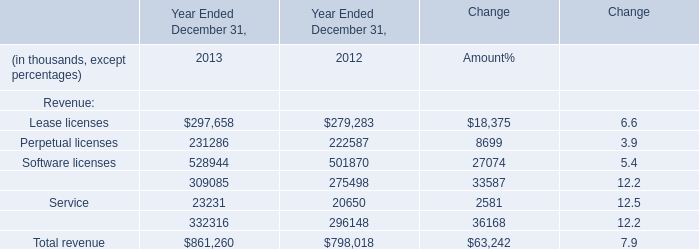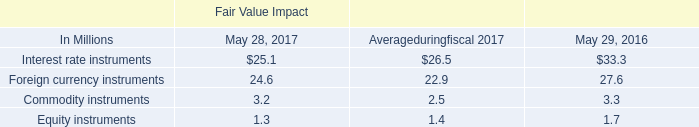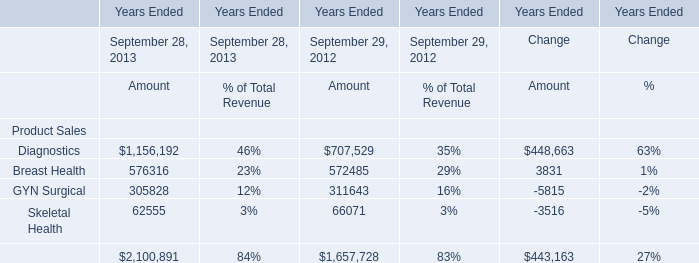What is the total amount of Maintenance and service of Year Ended December 31, 2013, and Skeletal Health of Years Ended September 29, 2012 Amount ? 
Computations: (332316.0 + 66071.0)
Answer: 398387.0. 